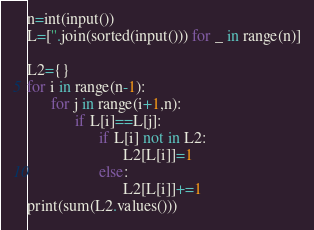Convert code to text. <code><loc_0><loc_0><loc_500><loc_500><_Python_>n=int(input())
L=[''.join(sorted(input())) for _ in range(n)]

L2={}
for i in range(n-1):
      for j in range(i+1,n):
            if L[i]==L[j]:
                  if L[i] not in L2:
                        L2[L[i]]=1
                  else:
                        L2[L[i]]+=1
print(sum(L2.values()))</code> 